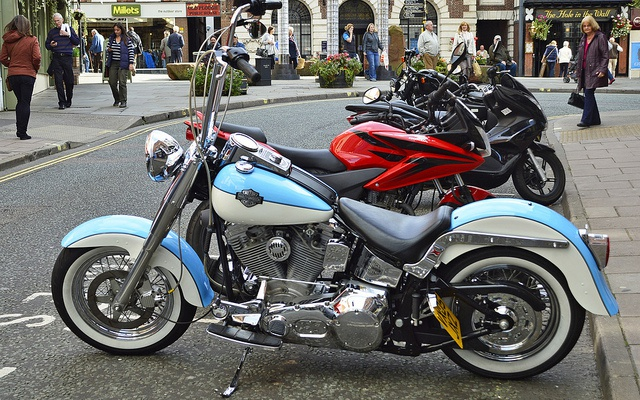Describe the objects in this image and their specific colors. I can see motorcycle in gray, black, darkgray, and lightgray tones, motorcycle in gray, black, and maroon tones, motorcycle in gray, black, and darkgray tones, people in gray, black, lightgray, and darkgray tones, and people in gray, black, maroon, and brown tones in this image. 